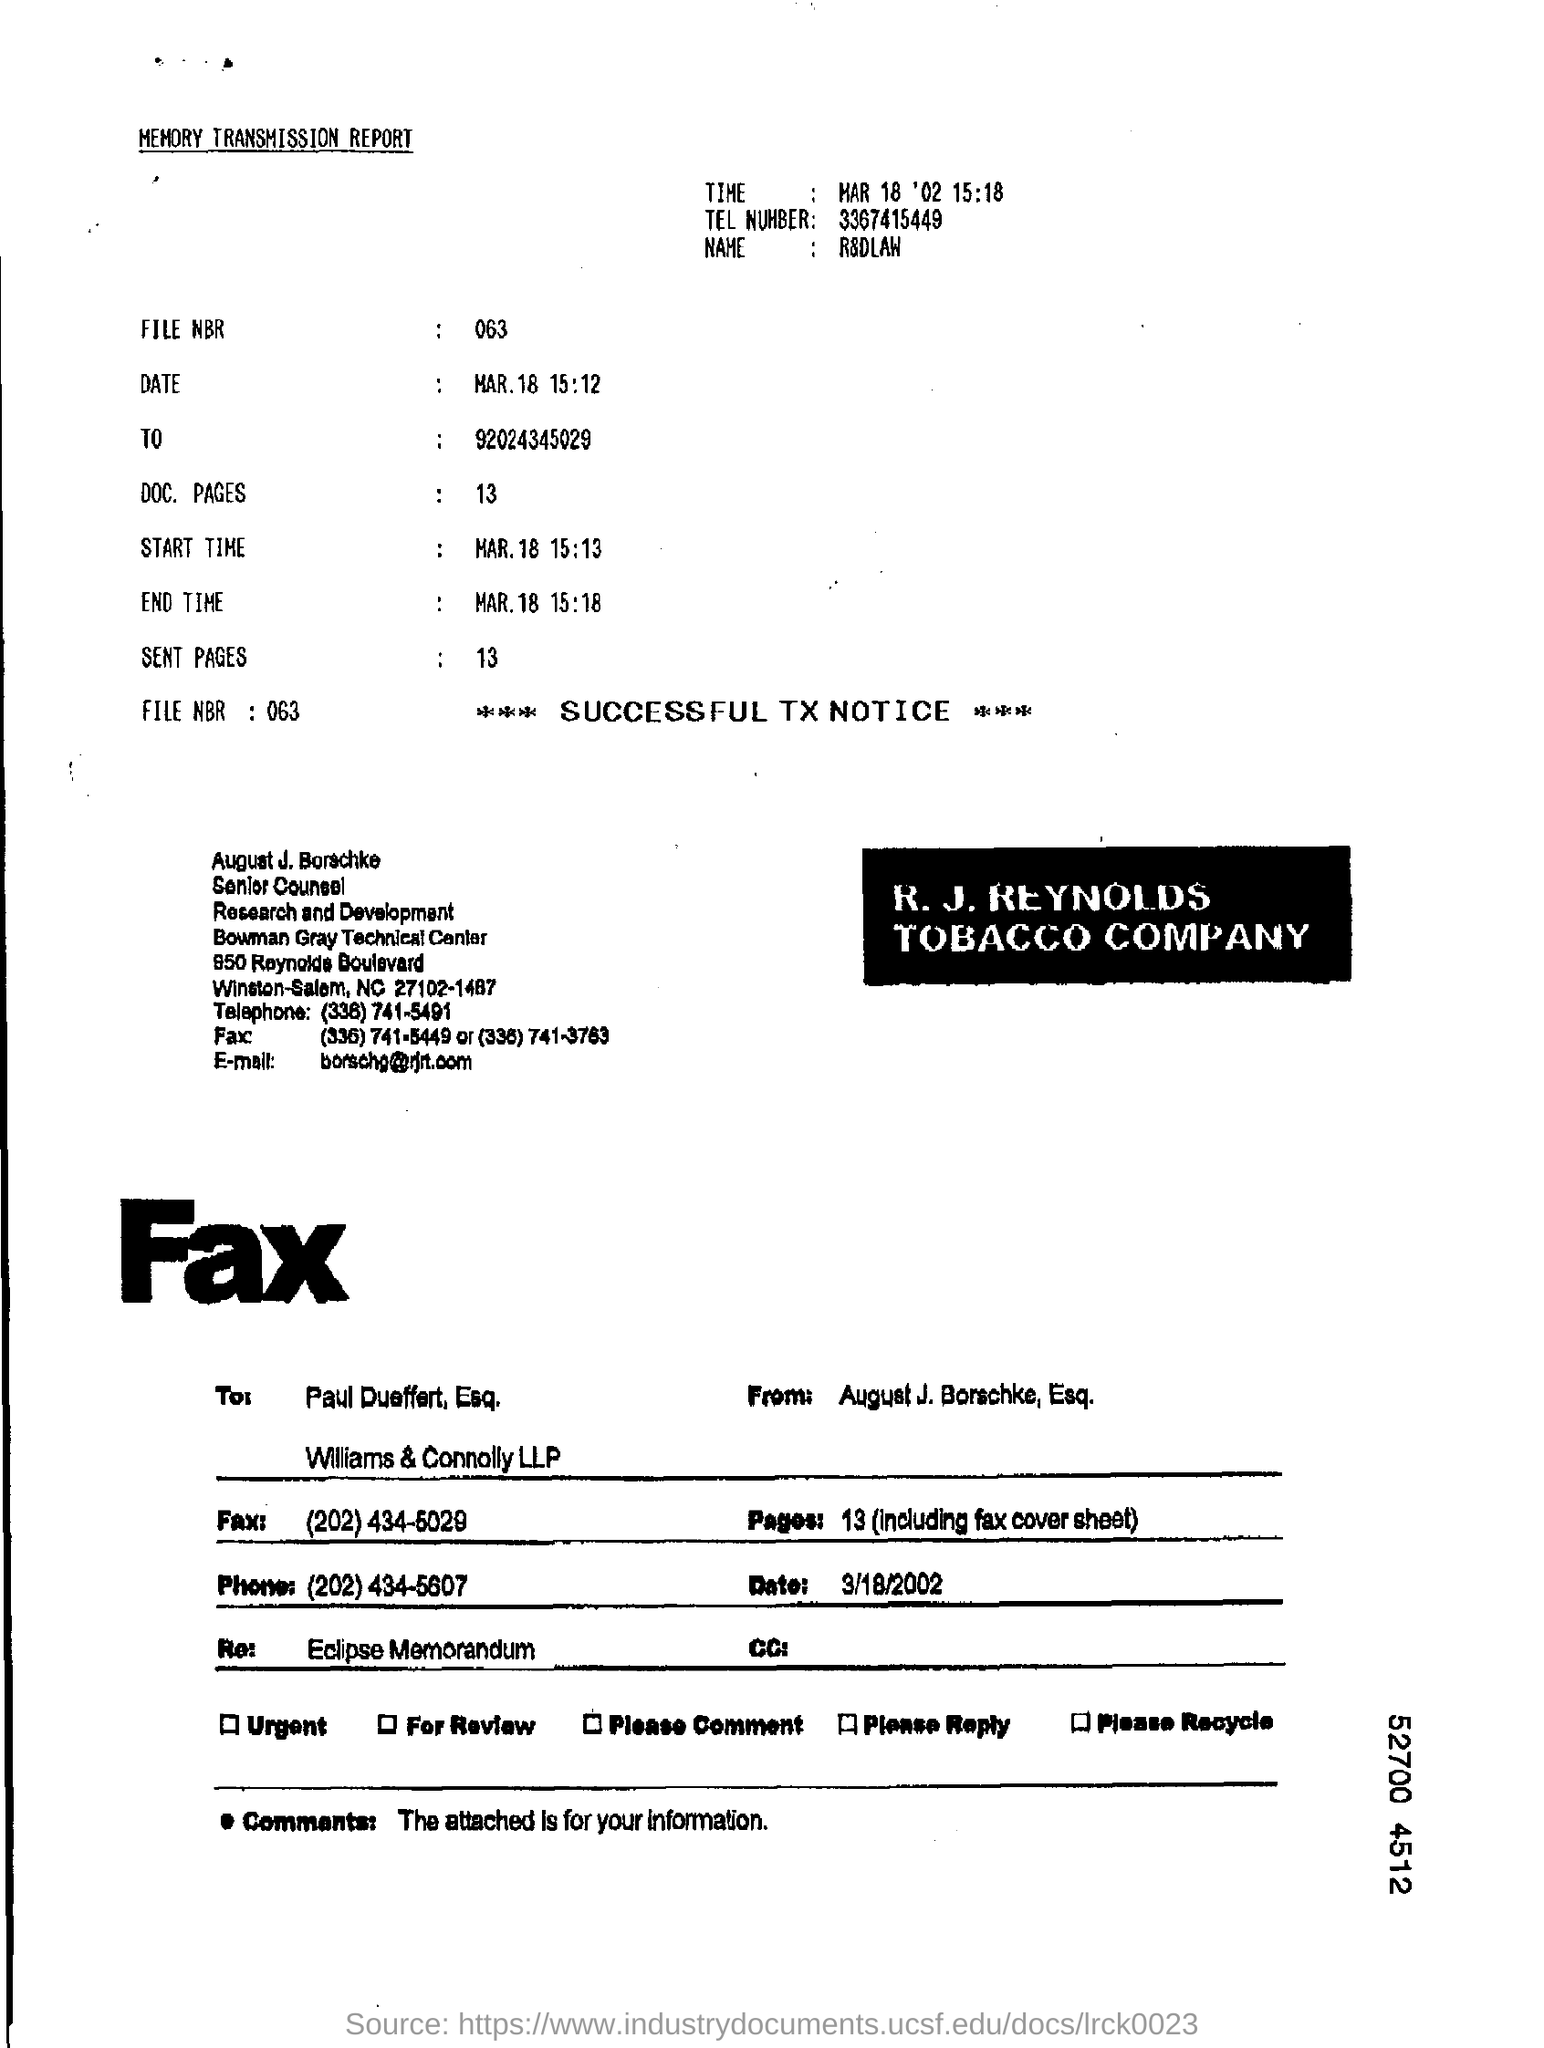Highlight a few significant elements in this photo. This fax is from August J. Borschke. The File NBR is 063. 